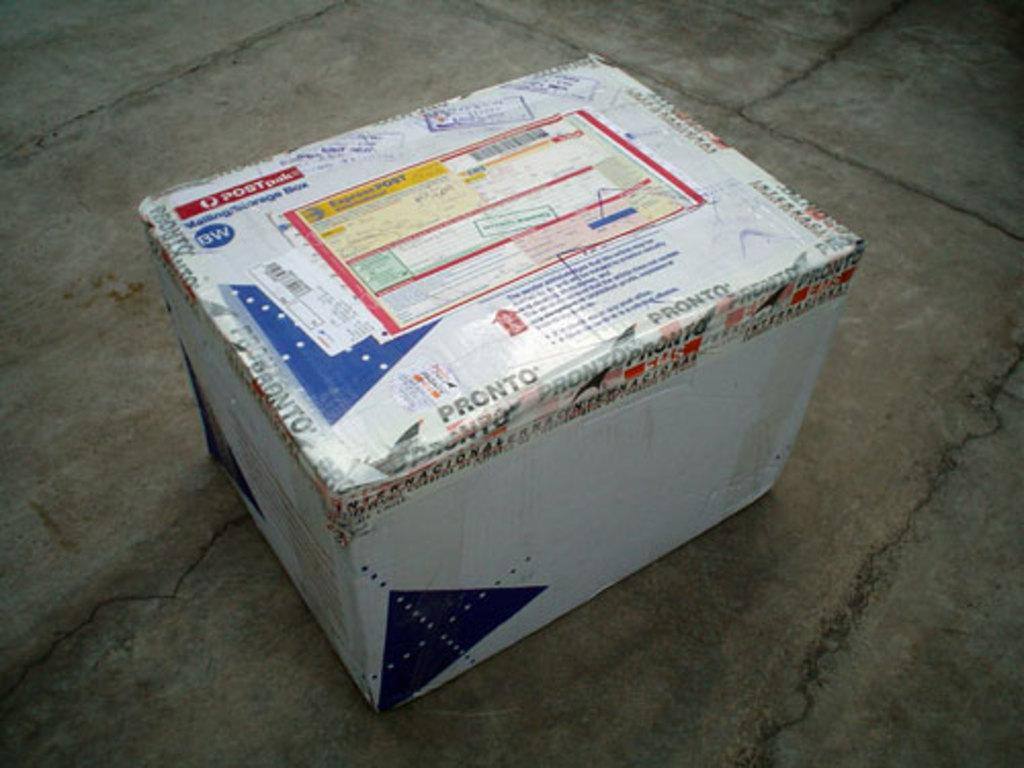What is the main object in the image? There is a cotton box in the image. Where is the cotton box located? The cotton box is on the floor. Is there any additional information about the cotton box? Yes, there is a sticker on the cotton box. How does the cotton box make you feel when you look at it in the image? The cotton box itself does not evoke feelings; it is an inanimate object. The image may evoke feelings, but the cotton box itself does not have the ability to make someone feel a certain way. 